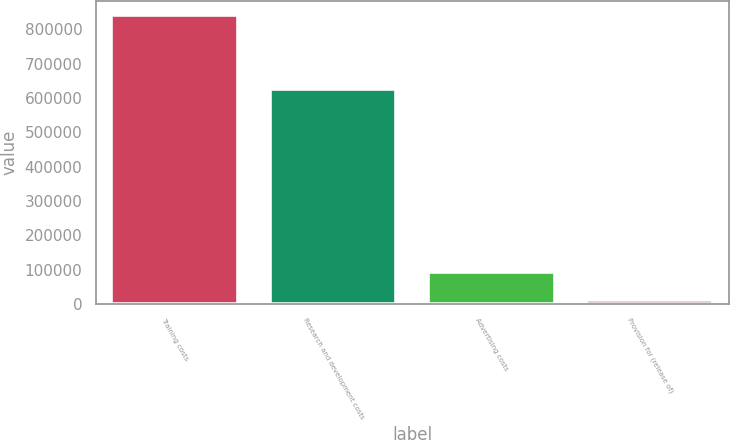Convert chart. <chart><loc_0><loc_0><loc_500><loc_500><bar_chart><fcel>Training costs<fcel>Research and development costs<fcel>Advertising costs<fcel>Provision for (release of)<nl><fcel>841440<fcel>625541<fcel>93446.4<fcel>10336<nl></chart> 